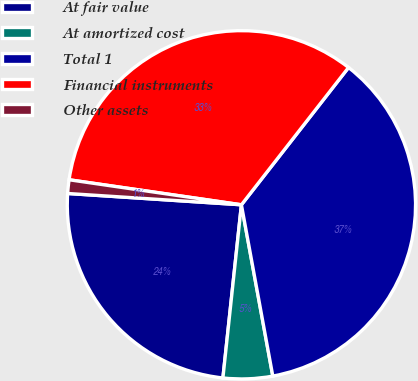Convert chart. <chart><loc_0><loc_0><loc_500><loc_500><pie_chart><fcel>At fair value<fcel>At amortized cost<fcel>Total 1<fcel>Financial instruments<fcel>Other assets<nl><fcel>24.34%<fcel>4.58%<fcel>36.57%<fcel>33.25%<fcel>1.26%<nl></chart> 